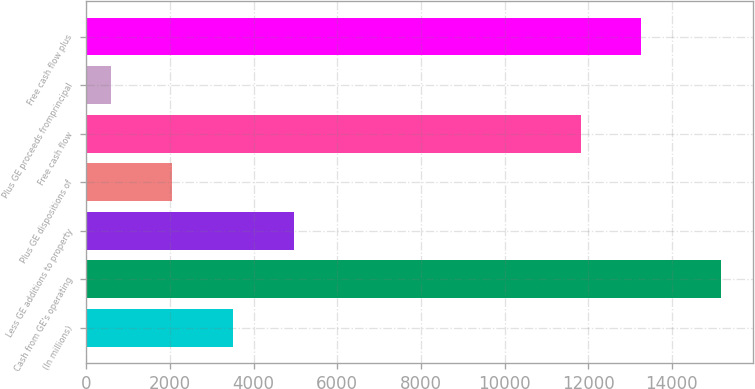Convert chart. <chart><loc_0><loc_0><loc_500><loc_500><bar_chart><fcel>(In millions)<fcel>Cash from GE's operating<fcel>Less GE additions to property<fcel>Plus GE dispositions of<fcel>Free cash flow<fcel>Plus GE proceeds fromprincipal<fcel>Free cash flow plus<nl><fcel>3515.8<fcel>15171<fcel>4972.7<fcel>2058.9<fcel>11816<fcel>602<fcel>13272.9<nl></chart> 